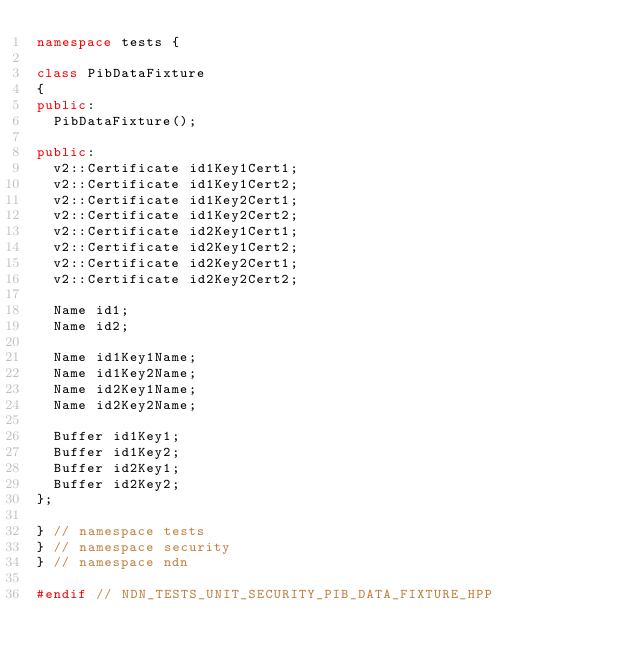Convert code to text. <code><loc_0><loc_0><loc_500><loc_500><_C++_>namespace tests {

class PibDataFixture
{
public:
  PibDataFixture();

public:
  v2::Certificate id1Key1Cert1;
  v2::Certificate id1Key1Cert2;
  v2::Certificate id1Key2Cert1;
  v2::Certificate id1Key2Cert2;
  v2::Certificate id2Key1Cert1;
  v2::Certificate id2Key1Cert2;
  v2::Certificate id2Key2Cert1;
  v2::Certificate id2Key2Cert2;

  Name id1;
  Name id2;

  Name id1Key1Name;
  Name id1Key2Name;
  Name id2Key1Name;
  Name id2Key2Name;

  Buffer id1Key1;
  Buffer id1Key2;
  Buffer id2Key1;
  Buffer id2Key2;
};

} // namespace tests
} // namespace security
} // namespace ndn

#endif // NDN_TESTS_UNIT_SECURITY_PIB_DATA_FIXTURE_HPP
</code> 